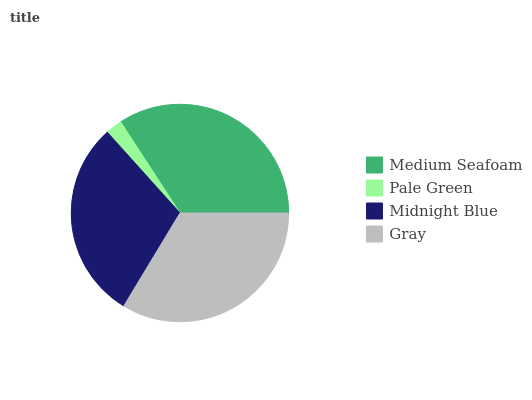Is Pale Green the minimum?
Answer yes or no. Yes. Is Medium Seafoam the maximum?
Answer yes or no. Yes. Is Midnight Blue the minimum?
Answer yes or no. No. Is Midnight Blue the maximum?
Answer yes or no. No. Is Midnight Blue greater than Pale Green?
Answer yes or no. Yes. Is Pale Green less than Midnight Blue?
Answer yes or no. Yes. Is Pale Green greater than Midnight Blue?
Answer yes or no. No. Is Midnight Blue less than Pale Green?
Answer yes or no. No. Is Gray the high median?
Answer yes or no. Yes. Is Midnight Blue the low median?
Answer yes or no. Yes. Is Medium Seafoam the high median?
Answer yes or no. No. Is Gray the low median?
Answer yes or no. No. 